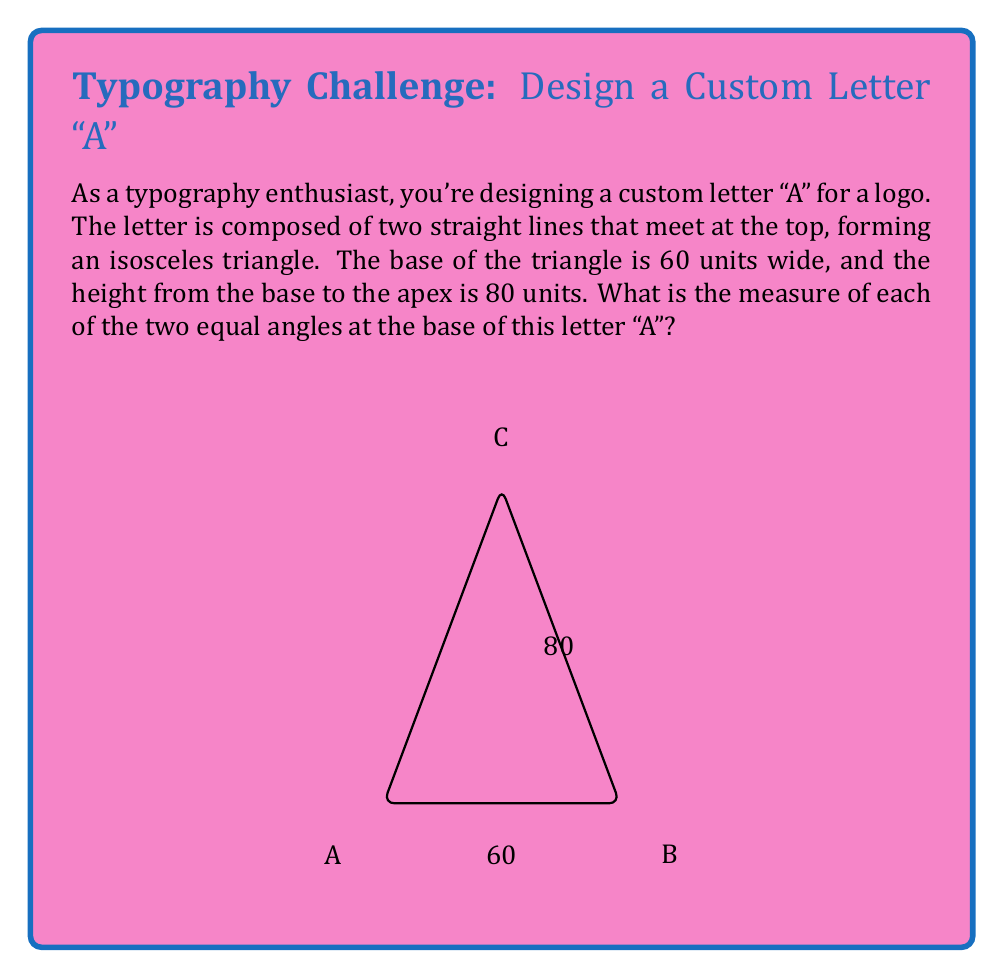Show me your answer to this math problem. Let's approach this step-by-step:

1) First, we need to recognize that we're dealing with an isosceles triangle. The two equal sides are the sides of the letter "A".

2) In an isosceles triangle, the angles opposite the equal sides are also equal. So, the two angles at the base of our letter "A" are equal.

3) We can split this isosceles triangle into two right triangles by drawing a perpendicular line from the apex to the base. This line will bisect the base.

4) Now we have a right triangle where:
   - The base is half of the original base: $30$ units
   - The height is the same: $80$ units

5) We can use the tangent function to find the angle:

   $$\tan(\theta) = \frac{\text{opposite}}{\text{adjacent}} = \frac{80}{30}$$

6) To find $\theta$, we take the inverse tangent (arctangent):

   $$\theta = \arctan(\frac{80}{30})$$

7) Using a calculator or computer:

   $$\theta \approx 69.44^\circ$$

8) This angle $\theta$ is the angle between the base and one side of the letter "A". The angle we're looking for is the complement of this angle:

   $$90^\circ - 69.44^\circ = 20.56^\circ$$

This is the measure of each of the two equal angles at the base of the letter "A".
Answer: The measure of each of the two equal angles at the base of the letter "A" is approximately $20.56^\circ$. 